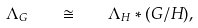<formula> <loc_0><loc_0><loc_500><loc_500>\Lambda _ { G } \quad \cong \quad \Lambda _ { H } \ast ( G / H ) ,</formula> 